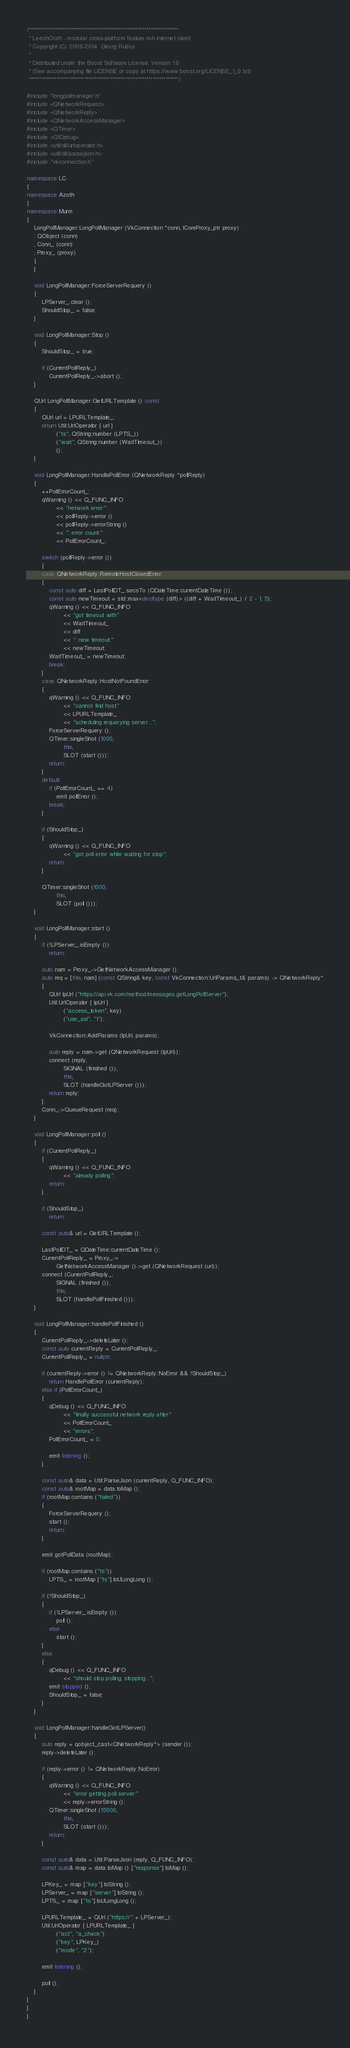Convert code to text. <code><loc_0><loc_0><loc_500><loc_500><_C++_>/**********************************************************************
 * LeechCraft - modular cross-platform feature rich internet client.
 * Copyright (C) 2006-2014  Georg Rudoy
 *
 * Distributed under the Boost Software License, Version 1.0.
 * (See accompanying file LICENSE or copy at https://www.boost.org/LICENSE_1_0.txt)
 **********************************************************************/

#include "longpollmanager.h"
#include <QNetworkRequest>
#include <QNetworkReply>
#include <QNetworkAccessManager>
#include <QTimer>
#include <QtDebug>
#include <util/sll/urloperator.h>
#include <util/sll/parsejson.h>
#include "vkconnection.h"

namespace LC
{
namespace Azoth
{
namespace Murm
{
	LongPollManager::LongPollManager (VkConnection *conn, ICoreProxy_ptr proxy)
	: QObject (conn)
	, Conn_ (conn)
	, Proxy_ (proxy)
	{
	}

	void LongPollManager::ForceServerRequery ()
	{
		LPServer_.clear ();
		ShouldStop_ = false;
	}

	void LongPollManager::Stop ()
	{
		ShouldStop_ = true;

		if (CurrentPollReply_)
			CurrentPollReply_->abort ();
	}

	QUrl LongPollManager::GetURLTemplate () const
	{
		QUrl url = LPURLTemplate_;
		return Util::UrlOperator { url }
				("ts", QString::number (LPTS_))
				("wait", QString::number (WaitTimeout_))
				();
	}

	void LongPollManager::HandlePollError (QNetworkReply *pollReply)
	{
		++PollErrorCount_;
		qWarning () << Q_FUNC_INFO
				<< "network error:"
				<< pollReply->error ()
				<< pollReply->errorString ()
				<< "; error count:"
				<< PollErrorCount_;

		switch (pollReply->error ())
		{
		case QNetworkReply::RemoteHostClosedError:
		{
			const auto diff = LastPollDT_.secsTo (QDateTime::currentDateTime ());
			const auto newTimeout = std::max<decltype (diff)> ((diff + WaitTimeout_) / 2 - 1, 5);
			qWarning () << Q_FUNC_INFO
					<< "got timeout with"
					<< WaitTimeout_
					<< diff
					<< "; new timeout:"
					<< newTimeout;
			WaitTimeout_ = newTimeout;
			break;
		}
		case QNetworkReply::HostNotFoundError:
		{
			qWarning () << Q_FUNC_INFO
					<< "cannot find host"
					<< LPURLTemplate_
					<< "scheduling requerying server...";
			ForceServerRequery ();
			QTimer::singleShot (1000,
					this,
					SLOT (start ()));
			return;
		}
		default:
			if (PollErrorCount_ == 4)
				emit pollError ();
			break;
		}

		if (ShouldStop_)
		{
			qWarning () << Q_FUNC_INFO
					<< "got poll error while waiting for stop";
			return;
		}

		QTimer::singleShot (1000,
				this,
				SLOT (poll ()));
	}

	void LongPollManager::start ()
	{
		if (!LPServer_.isEmpty ())
			return;

		auto nam = Proxy_->GetNetworkAccessManager ();
		auto req = [this, nam] (const QString& key, const VkConnection::UrlParams_t& params) -> QNetworkReply*
		{
			QUrl lpUrl ("https://api.vk.com/method/messages.getLongPollServer");
			Util::UrlOperator { lpUrl }
					("access_token", key)
					("use_ssl", "1");

			VkConnection::AddParams (lpUrl, params);

			auto reply = nam->get (QNetworkRequest (lpUrl));
			connect (reply,
					SIGNAL (finished ()),
					this,
					SLOT (handleGotLPServer ()));
			return reply;
		};
		Conn_->QueueRequest (req);
	}

	void LongPollManager::poll ()
	{
		if (CurrentPollReply_)
		{
			qWarning () << Q_FUNC_INFO
					<< "already polling";
			return;
		}

		if (ShouldStop_)
			return;

		const auto& url = GetURLTemplate ();

		LastPollDT_ = QDateTime::currentDateTime ();
		CurrentPollReply_ = Proxy_->
				GetNetworkAccessManager ()->get (QNetworkRequest (url));
		connect (CurrentPollReply_,
				SIGNAL (finished ()),
				this,
				SLOT (handlePollFinished ()));
	}

	void LongPollManager::handlePollFinished ()
	{
		CurrentPollReply_->deleteLater ();
		const auto currentReply = CurrentPollReply_;
		CurrentPollReply_ = nullptr;

		if (currentReply->error () != QNetworkReply::NoError && !ShouldStop_)
			return HandlePollError (currentReply);
		else if (PollErrorCount_)
		{
			qDebug () << Q_FUNC_INFO
					<< "finally successful network reply after"
					<< PollErrorCount_
					<< "errors";
			PollErrorCount_ = 0;

			emit listening ();
		}

		const auto& data = Util::ParseJson (currentReply, Q_FUNC_INFO);
		const auto& rootMap = data.toMap ();
		if (rootMap.contains ("failed"))
		{
			ForceServerRequery ();
			start ();
			return;
		}

		emit gotPollData (rootMap);

		if (rootMap.contains ("ts"))
			LPTS_ = rootMap ["ts"].toULongLong ();

		if (!ShouldStop_)
		{
			if (!LPServer_.isEmpty ())
				poll ();
			else
				start ();
		}
		else
		{
			qDebug () << Q_FUNC_INFO
					<< "should stop polling, stopping...";
			emit stopped ();
			ShouldStop_ = false;
		}
	}

	void LongPollManager::handleGotLPServer()
	{
		auto reply = qobject_cast<QNetworkReply*> (sender ());
		reply->deleteLater ();

		if (reply->error () != QNetworkReply::NoError)
		{
			qWarning () << Q_FUNC_INFO
					<< "error getting poll server:"
					<< reply->errorString ();
			QTimer::singleShot (15000,
					this,
					SLOT (start ()));
			return;
		}

		const auto& data = Util::ParseJson (reply, Q_FUNC_INFO);
		const auto& map = data.toMap () ["response"].toMap ();

		LPKey_ = map ["key"].toString ();
		LPServer_ = map ["server"].toString ();
		LPTS_ = map ["ts"].toULongLong ();

		LPURLTemplate_ = QUrl ("https://" + LPServer_);
		Util::UrlOperator { LPURLTemplate_ }
				("act", "a_check")
				("key", LPKey_)
				("mode", "2");

		emit listening ();

		poll ();
	}
}
}
}
</code> 